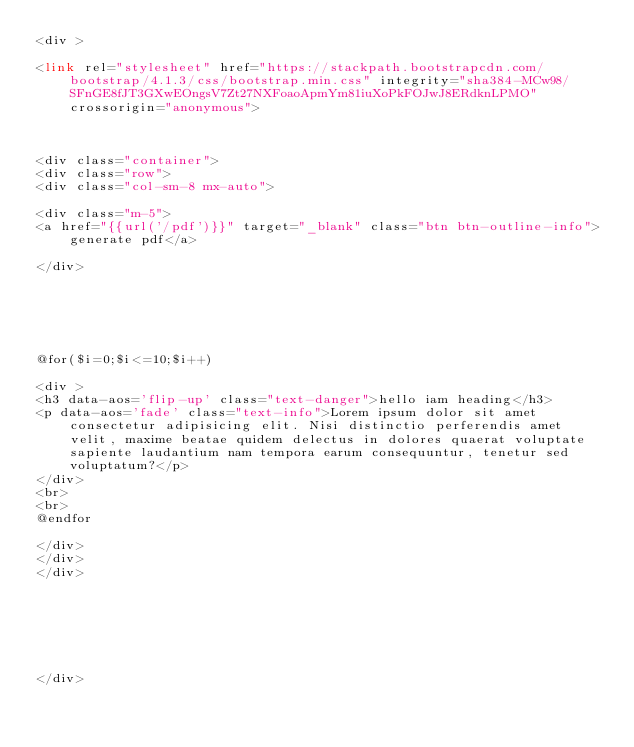Convert code to text. <code><loc_0><loc_0><loc_500><loc_500><_PHP_><div >

<link rel="stylesheet" href="https://stackpath.bootstrapcdn.com/bootstrap/4.1.3/css/bootstrap.min.css" integrity="sha384-MCw98/SFnGE8fJT3GXwEOngsV7Zt27NXFoaoApmYm81iuXoPkFOJwJ8ERdknLPMO" crossorigin="anonymous">



<div class="container">
<div class="row">
<div class="col-sm-8 mx-auto">

<div class="m-5">
<a href="{{url('/pdf')}}" target="_blank" class="btn btn-outline-info">generate pdf</a>

</div>  






@for($i=0;$i<=10;$i++)

<div >
<h3 data-aos='flip-up' class="text-danger">hello iam heading</h3>
<p data-aos='fade' class="text-info">Lorem ipsum dolor sit amet consectetur adipisicing elit. Nisi distinctio perferendis amet velit, maxime beatae quidem delectus in dolores quaerat voluptate sapiente laudantium nam tempora earum consequuntur, tenetur sed voluptatum?</p>
</div>
<br>
<br>
@endfor

</div>
</div>
</div>







</div></code> 